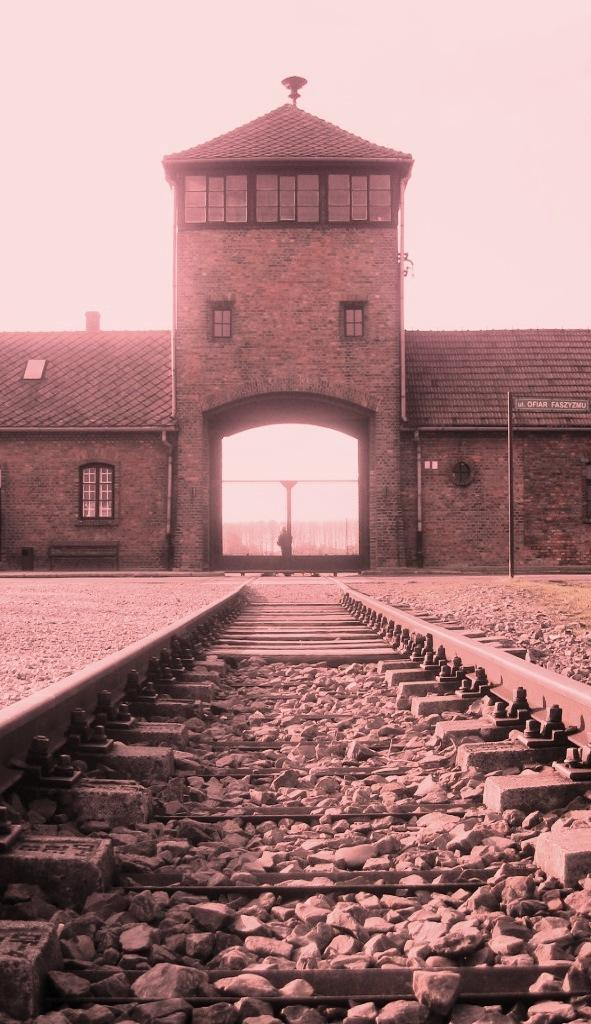What type of structure is visible in the image? There is a building in the image. What other objects can be seen related to the building? There are pipelines, windows, a chimney, and a pole visible in the image. What is the ground like in the image? The ground is visible in the image, and there are stones present. What else can be seen in the image related to transportation? A railway track is present in the image. What part of the natural environment is visible in the image? The sky is visible in the image. How many cars are parked at the station in the image? There is no station or cars present in the image. What is the comparison between the building in the image and the building next to it? There is no other building present in the image for comparison. 